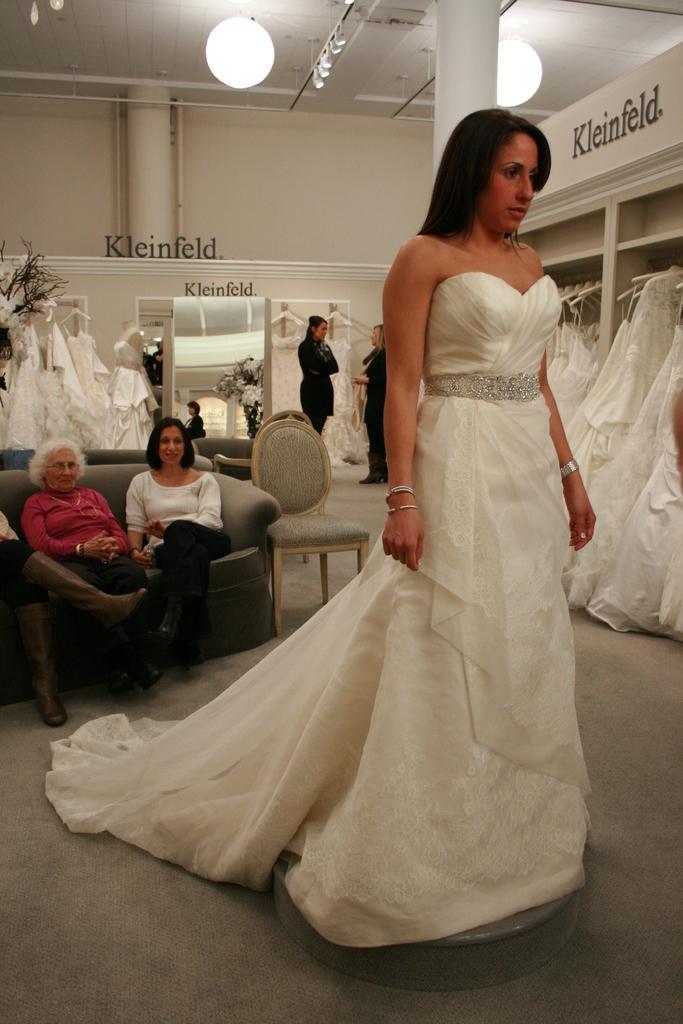Please provide a concise description of this image. In this image we can see few people, some of them are sitting on the couch and few of them are standing on the floor, there are few clothes hanged and there is a pillar, a light to the ceiling a mirror and text to the wall. 